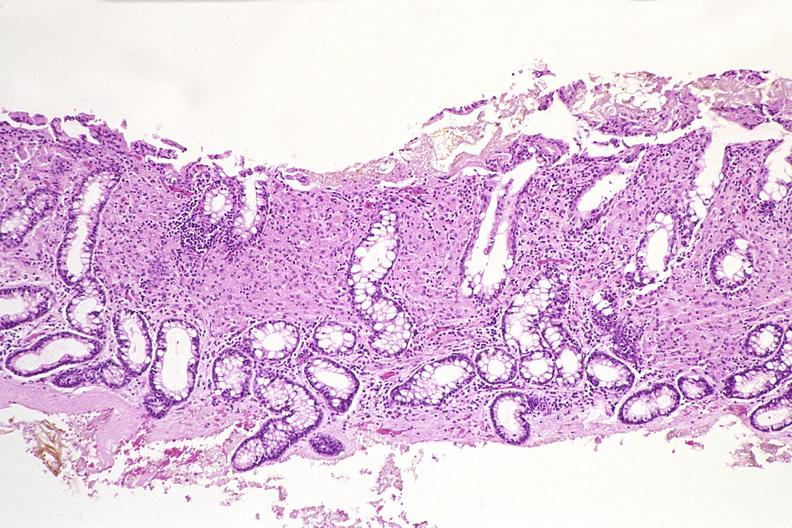what is present?
Answer the question using a single word or phrase. Gastrointestinal 